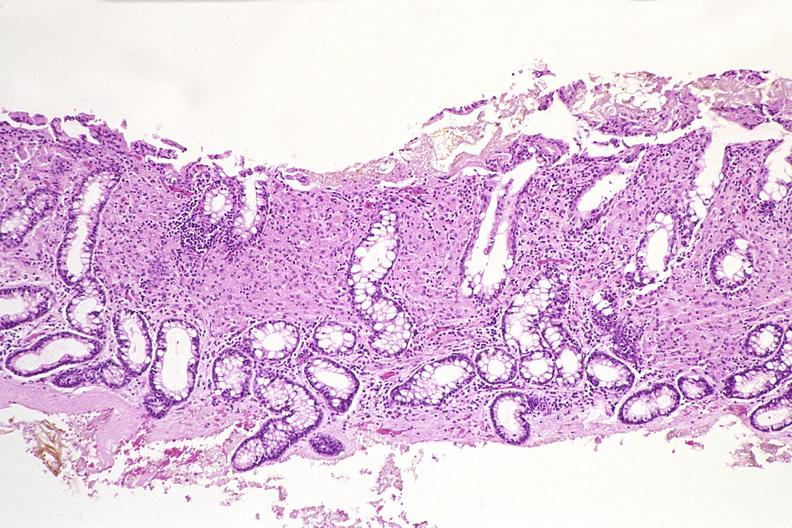what is present?
Answer the question using a single word or phrase. Gastrointestinal 